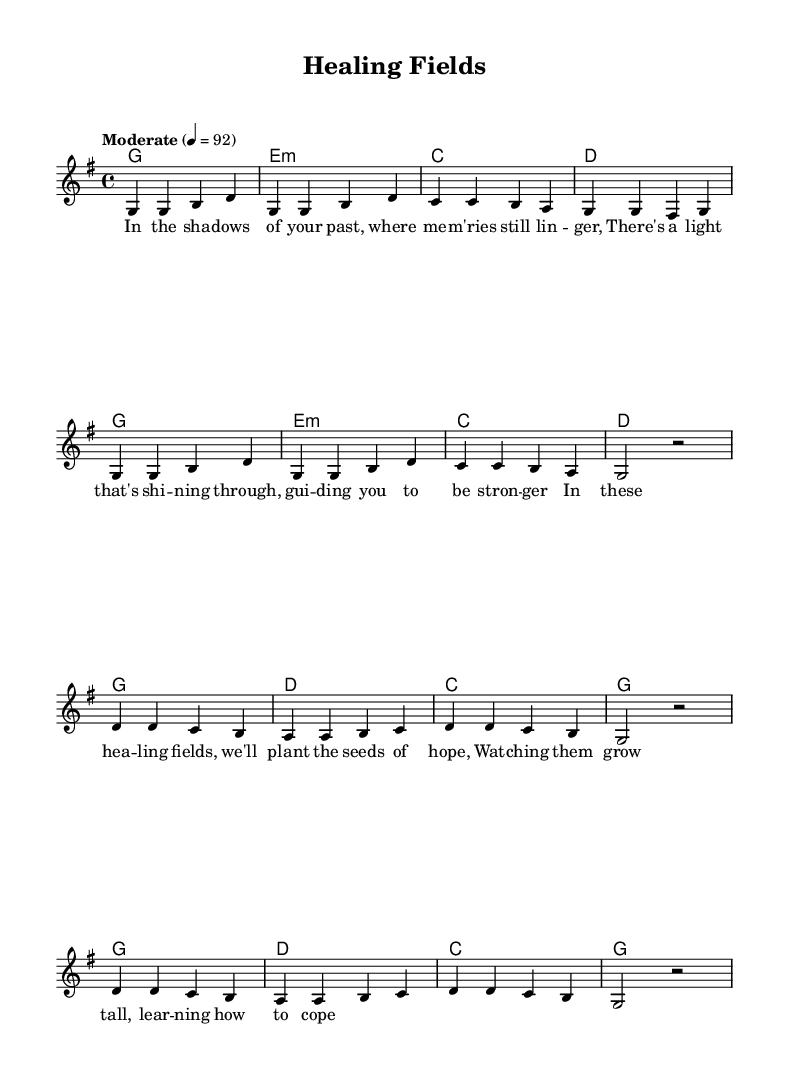What is the key signature of this music? The key signature is G major, which has one sharp (F#).
Answer: G major What is the time signature of this music? The time signature is 4/4, indicating four beats per measure.
Answer: 4/4 What is the tempo marking for the piece? The tempo marking indicates a moderate speed of 92 beats per minute.
Answer: Moderate How many measures are in the verse section? The verse contains eight measures, as represented by the sequence of notes before the chorus.
Answer: Eight What is the primary theme of the lyrics in this piece? The lyrics focus on healing and overcoming trauma, emphasizing hope and resilience.
Answer: Healing and overcoming trauma How many times is the chorus repeated in the score? The chorus is repeated two times in the score, displayed in the musical notation.
Answer: Two times What type of chords are primarily used in the verse section? The verse predominantly uses major and minor chords, contributing to a hopeful tone.
Answer: Major and minor chords 